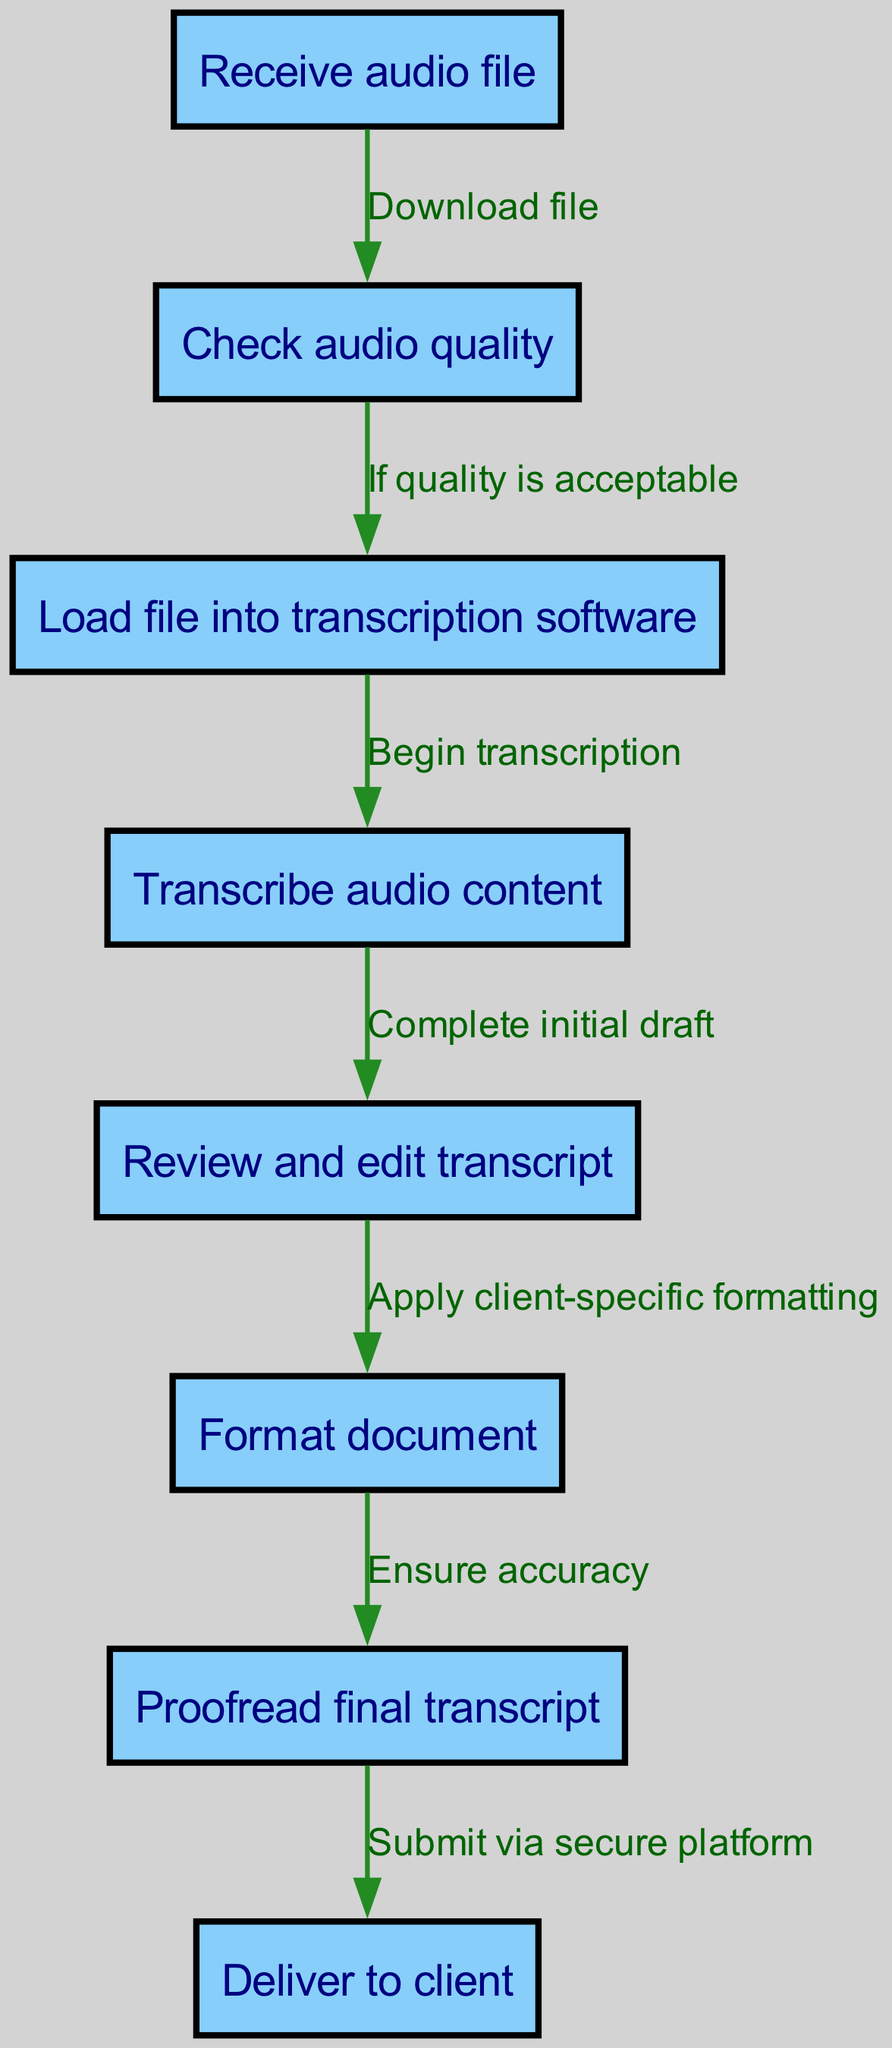What is the first step in the transcription process? The diagram indicates that the first node is labeled "Receive audio file." This is the starting point of the transcription process and serves as the initial action taken before any further steps.
Answer: Receive audio file How many nodes are in the diagram? By counting the nodes listed in the diagram's data, there are a total of eight nodes (from receiving the audio file to delivering the final transcript).
Answer: Eight What happens if the audio quality is acceptable? The diagram shows that if the audio quality is acceptable, the process continues to the next node, which is "Load file into transcription software." This indicates that the workflow depends on the condition of audio quality.
Answer: Load file into transcription software What is the relationship between the "Review and edit transcript" and "Format document"? The relationship depicted in the diagram is a direct flow from "Review and edit transcript" to "Format document," indicating that formatting occurs after reviewing and editing. This establishes the sequence of actions within the process.
Answer: Apply client-specific formatting What is the final step before delivering the transcript? The diagram shows that the last step before delivery is "Proofread final transcript." It is an essential action that ensures accuracy and correctness of the document prior to submission.
Answer: Proofread final transcript What step follows the completion of the initial draft? According to the flowchart, after "Complete initial draft," the next step is "Review and edit transcript." This shows that reviewing follows the transcribing of the audio content.
Answer: Review and edit transcript In how many steps does the transcription process transition from the audio file receipt to the final delivery? The diagram presents a flow of steps involving a total of seven transitions from the receipt of the audio file to the delivery of the final document, accounting each edge as a step.
Answer: Seven transitions What type of platform is used for submission to clients? The last node indicates that the transcript is "Submit via secure platform," which highlights the importance of using secure channels for delivering sensitive information.
Answer: Secure platform 